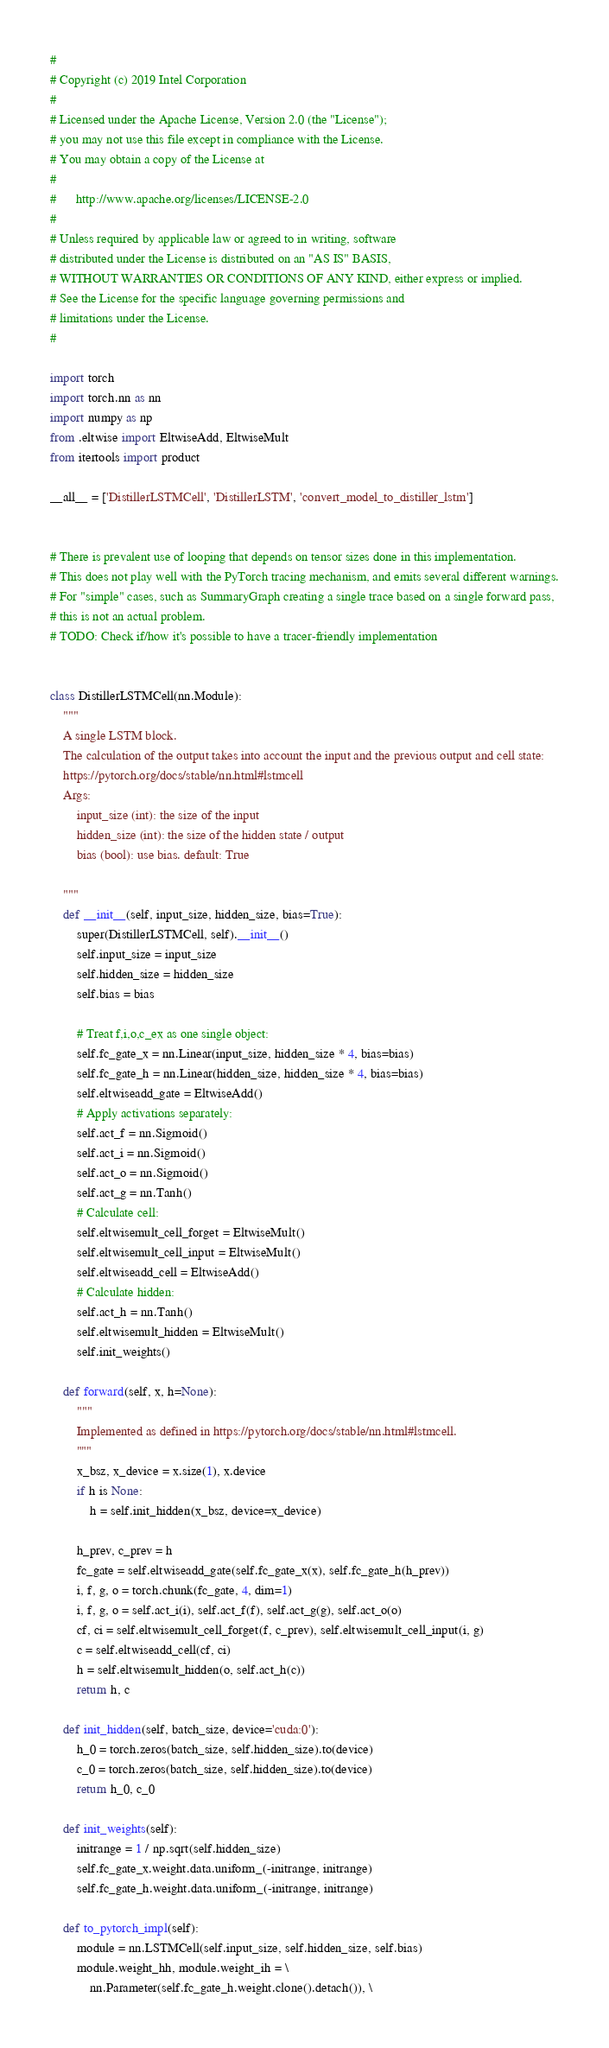<code> <loc_0><loc_0><loc_500><loc_500><_Python_>#
# Copyright (c) 2019 Intel Corporation
#
# Licensed under the Apache License, Version 2.0 (the "License");
# you may not use this file except in compliance with the License.
# You may obtain a copy of the License at
#
#      http://www.apache.org/licenses/LICENSE-2.0
#
# Unless required by applicable law or agreed to in writing, software
# distributed under the License is distributed on an "AS IS" BASIS,
# WITHOUT WARRANTIES OR CONDITIONS OF ANY KIND, either express or implied.
# See the License for the specific language governing permissions and
# limitations under the License.
#

import torch
import torch.nn as nn
import numpy as np
from .eltwise import EltwiseAdd, EltwiseMult
from itertools import product

__all__ = ['DistillerLSTMCell', 'DistillerLSTM', 'convert_model_to_distiller_lstm']


# There is prevalent use of looping that depends on tensor sizes done in this implementation.
# This does not play well with the PyTorch tracing mechanism, and emits several different warnings.
# For "simple" cases, such as SummaryGraph creating a single trace based on a single forward pass,
# this is not an actual problem.
# TODO: Check if/how it's possible to have a tracer-friendly implementation


class DistillerLSTMCell(nn.Module):
    """
    A single LSTM block.
    The calculation of the output takes into account the input and the previous output and cell state:
    https://pytorch.org/docs/stable/nn.html#lstmcell
    Args:
        input_size (int): the size of the input
        hidden_size (int): the size of the hidden state / output
        bias (bool): use bias. default: True

    """
    def __init__(self, input_size, hidden_size, bias=True):
        super(DistillerLSTMCell, self).__init__()
        self.input_size = input_size
        self.hidden_size = hidden_size
        self.bias = bias

        # Treat f,i,o,c_ex as one single object:
        self.fc_gate_x = nn.Linear(input_size, hidden_size * 4, bias=bias)
        self.fc_gate_h = nn.Linear(hidden_size, hidden_size * 4, bias=bias)
        self.eltwiseadd_gate = EltwiseAdd()
        # Apply activations separately:
        self.act_f = nn.Sigmoid()
        self.act_i = nn.Sigmoid()
        self.act_o = nn.Sigmoid()
        self.act_g = nn.Tanh()
        # Calculate cell:
        self.eltwisemult_cell_forget = EltwiseMult()
        self.eltwisemult_cell_input = EltwiseMult()
        self.eltwiseadd_cell = EltwiseAdd()
        # Calculate hidden:
        self.act_h = nn.Tanh()
        self.eltwisemult_hidden = EltwiseMult()
        self.init_weights()

    def forward(self, x, h=None):
        """
        Implemented as defined in https://pytorch.org/docs/stable/nn.html#lstmcell.
        """
        x_bsz, x_device = x.size(1), x.device
        if h is None:
            h = self.init_hidden(x_bsz, device=x_device)
        
        h_prev, c_prev = h
        fc_gate = self.eltwiseadd_gate(self.fc_gate_x(x), self.fc_gate_h(h_prev))
        i, f, g, o = torch.chunk(fc_gate, 4, dim=1)
        i, f, g, o = self.act_i(i), self.act_f(f), self.act_g(g), self.act_o(o)
        cf, ci = self.eltwisemult_cell_forget(f, c_prev), self.eltwisemult_cell_input(i, g)
        c = self.eltwiseadd_cell(cf, ci)
        h = self.eltwisemult_hidden(o, self.act_h(c))
        return h, c

    def init_hidden(self, batch_size, device='cuda:0'):
        h_0 = torch.zeros(batch_size, self.hidden_size).to(device)
        c_0 = torch.zeros(batch_size, self.hidden_size).to(device)
        return h_0, c_0

    def init_weights(self):
        initrange = 1 / np.sqrt(self.hidden_size)
        self.fc_gate_x.weight.data.uniform_(-initrange, initrange)
        self.fc_gate_h.weight.data.uniform_(-initrange, initrange)

    def to_pytorch_impl(self):
        module = nn.LSTMCell(self.input_size, self.hidden_size, self.bias)
        module.weight_hh, module.weight_ih = \
            nn.Parameter(self.fc_gate_h.weight.clone().detach()), \</code> 